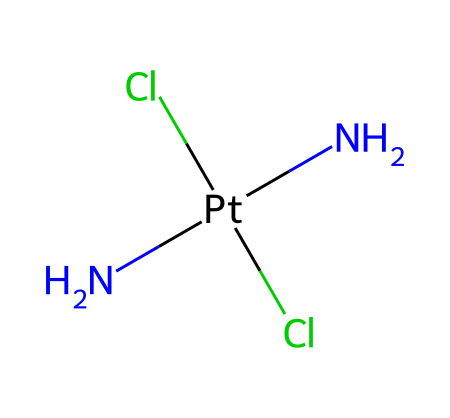what is the central metal ion in this compound? The SMILES representation shows 'Pt' which corresponds to platinum, indicating that platinum is the central metal ion in this coordination complex.
Answer: platinum how many chloride ions are present in the structure? The SMILES notation includes two 'Cl' symbols, signifying that there are two chloride ions attached to the platinum center.
Answer: two what type of coordination geometry is expected for this complex? The connectivity in the structure suggests a square planar geometry, which is typical for platinum(II) complexes due to the arrangement of ligands around the metal center.
Answer: square planar which ligands are coordinated to the platinum ion? The structure reveals two 'N' atoms and two 'Cl' atoms connected to platinum, indicating that the ligands are ammonia (NH3) and chloride.
Answer: ammonia and chloride how many total nitrogen atoms are in the coordination compound? The SMILES representation shows two 'N' atoms, indicating that there are two nitrogen atoms coordinated to the platinum ion in the structure.
Answer: two what role does cisplatin play in medical applications? Cisplatin is known as a chemotherapy drug primarily used to treat various types of cancer.
Answer: chemotherapy drug is this compound a bidentate or a monodentate ligand complex? In this compound, each ligand (both the nitrogen atoms from ammonia and chloride ions) coordinates via one site, making it a monodentate ligand complex overall.
Answer: monodentate 